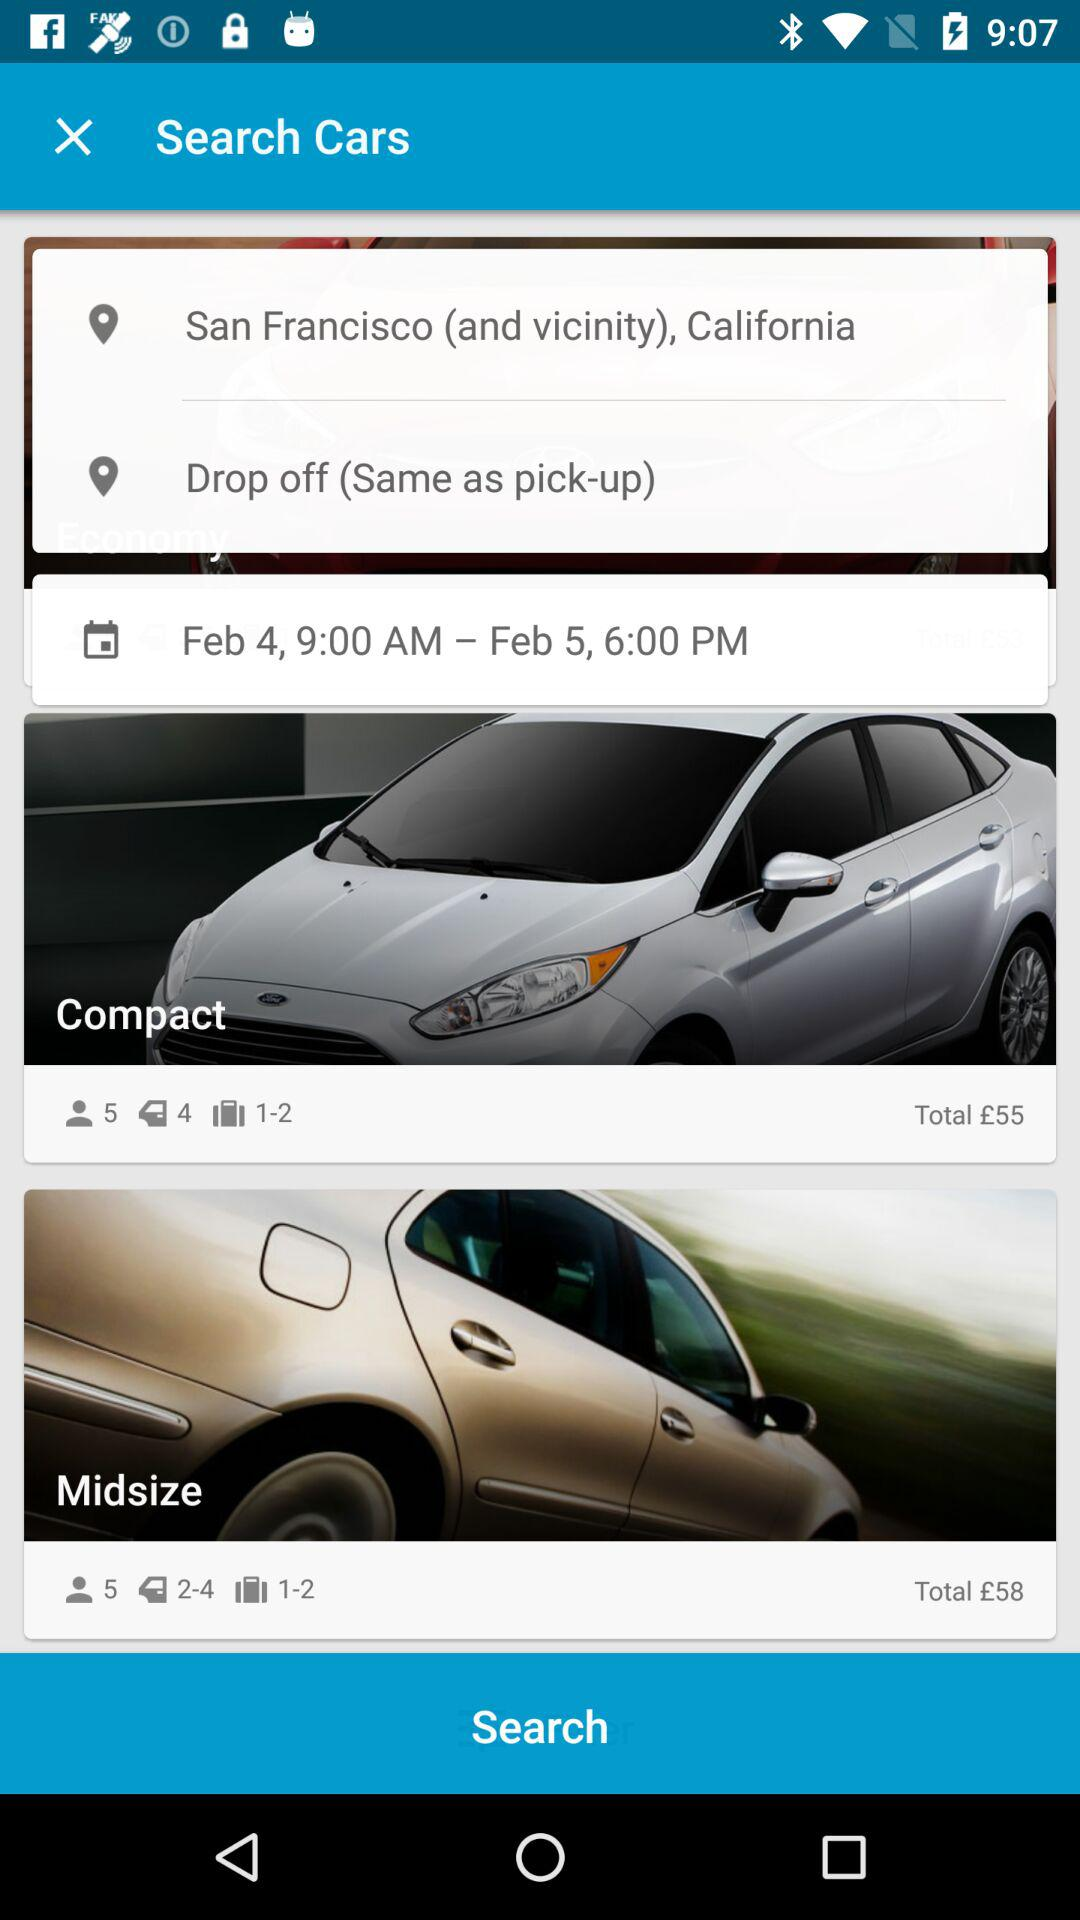What is the pickup location? The pickup location is San Francisco (and vicinity), California. 